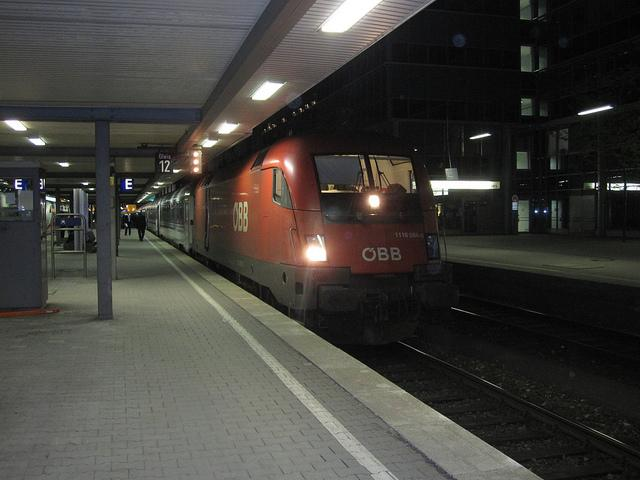What letter appears twice in a row on the train? letter b 